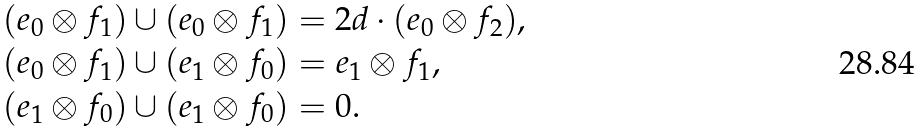<formula> <loc_0><loc_0><loc_500><loc_500>( e _ { 0 } \otimes f _ { 1 } ) \cup ( e _ { 0 } \otimes f _ { 1 } ) & = 2 d \cdot ( e _ { 0 } \otimes f _ { 2 } ) , \\ ( e _ { 0 } \otimes f _ { 1 } ) \cup ( e _ { 1 } \otimes f _ { 0 } ) & = e _ { 1 } \otimes f _ { 1 } , \\ ( e _ { 1 } \otimes f _ { 0 } ) \cup ( e _ { 1 } \otimes f _ { 0 } ) & = 0 .</formula> 